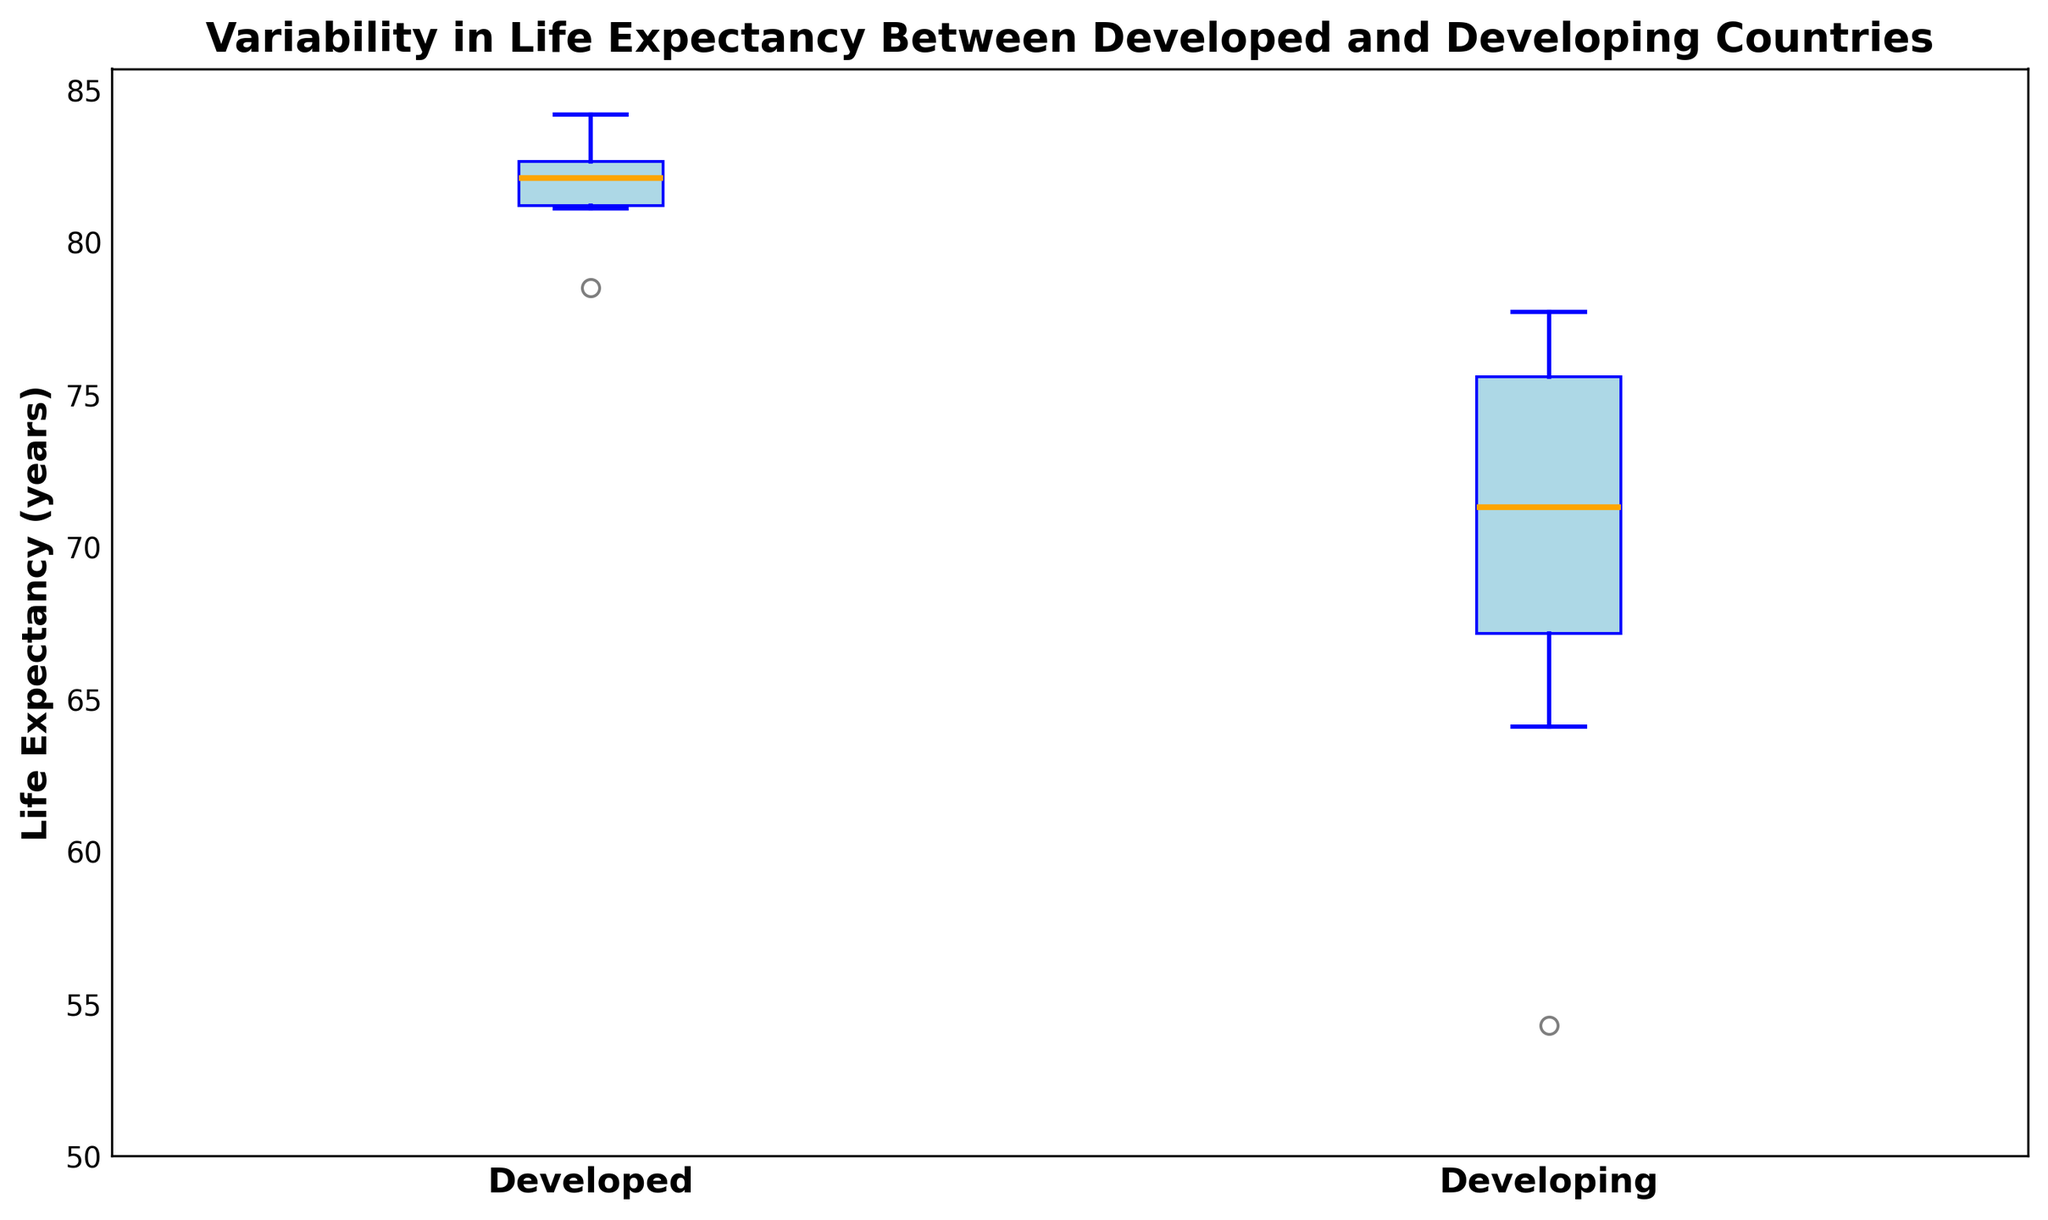What is the median life expectancy for developed countries? Locate the median line within the box plot for the 'Developed' group. The orange line within the box represents the median.
Answer: Around 82 years Which group has a higher median life expectancy, developed or developing countries? Compare the median lines of both box plots. The median line for 'Developed' is higher than 'Developing'.
Answer: Developed countries What is the range of life expectancy in developing countries? Identify the lowest and highest whiskers for the 'Developing' group. The range is the difference between these two.
Answer: Approximately 54 to 77 years Are there any outliers in the life expectancy data for developed countries? Outliers are represented as individual points outside the whiskers. Check if there are any points beyond the whiskers in the 'Developed' group.
Answer: No What is the difference between the median life expectancy of developed and developing countries? Find the median values for both groups and subtract the median of the developing countries from that of the developed countries.
Answer: Approximately 14 years Which group shows more variability in life expectancy, developed or developing countries? Variability can be inferred from the length of the box and the whiskers. The group with a longer box and whiskers has higher variability.
Answer: Developing countries What is the interquartile range (IQR) for developing countries? The IQR is the difference between the third quartile (top of the box) and the first quartile (bottom of the box) for the developing group.
Answer: Approximately 69 to 75 years How does the maximum life expectancy in developing countries compare to the minimum life expectancy in developed countries? Locate the top whisker of the 'Developing' group and the bottom whisker of the 'Developed' group and compare these values.
Answer: Maximum in developing countries is higher Is the life expectancy in developing countries generally lower than in developed countries? Overall, compare the positions of the boxes and whiskers of both groups. The lower positions of the developing countries' box indicate lower life expectancy.
Answer: Yes 